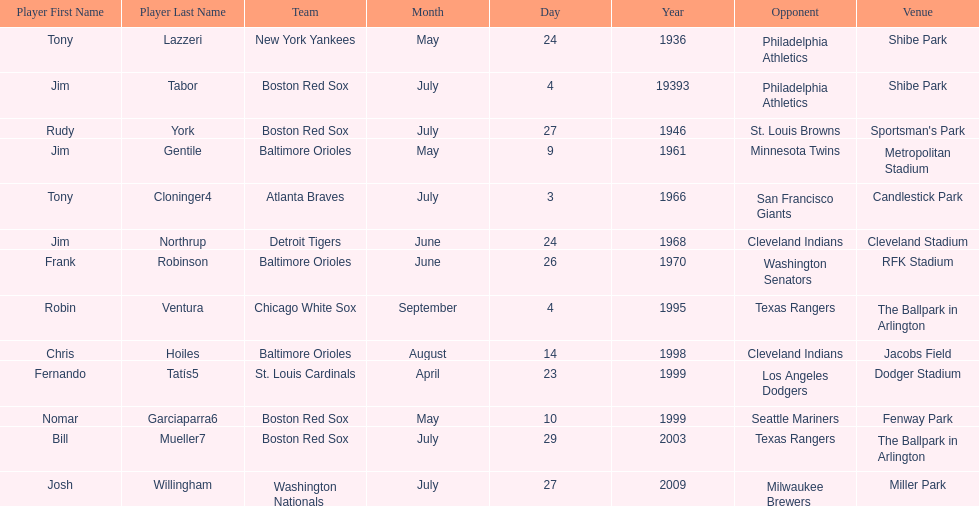What are the names of all the players? Tony Lazzeri, Jim Tabor, Rudy York, Jim Gentile, Tony Cloninger4, Jim Northrup, Frank Robinson, Robin Ventura, Chris Hoiles, Fernando Tatís5, Nomar Garciaparra6, Bill Mueller7, Josh Willingham. What are the names of all the teams holding home run records? New York Yankees, Boston Red Sox, Baltimore Orioles, Atlanta Braves, Detroit Tigers, Chicago White Sox, St. Louis Cardinals, Washington Nationals. Which player played for the new york yankees? Tony Lazzeri. 